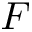Convert formula to latex. <formula><loc_0><loc_0><loc_500><loc_500>F</formula> 